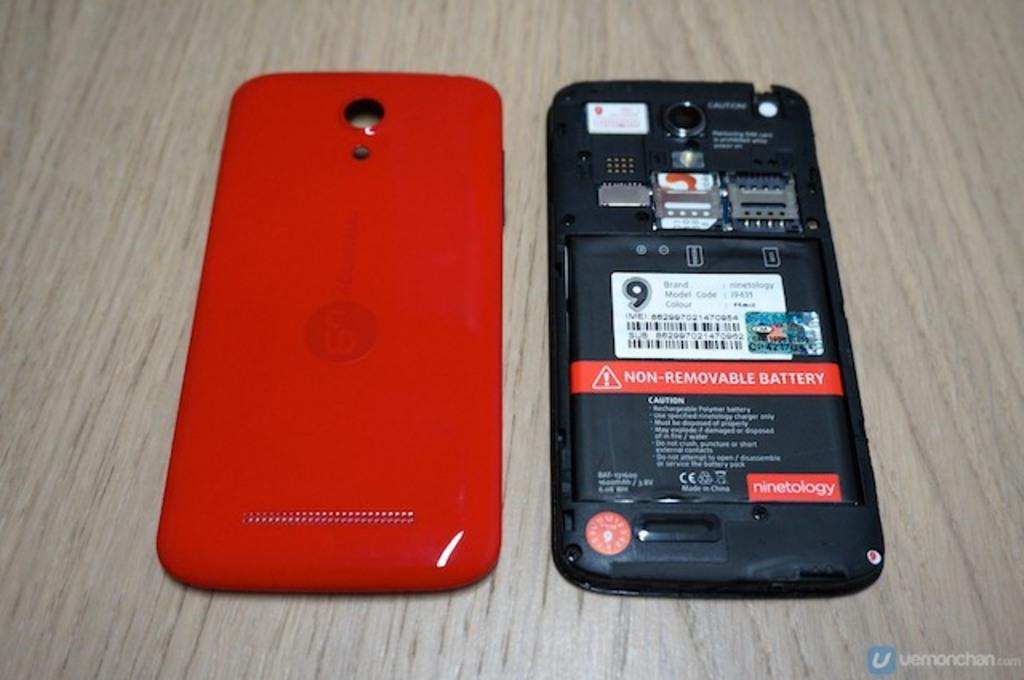<image>
Relay a brief, clear account of the picture shown. A phone with its red back removed and placed to the side now reveals its insides that say Non-Removable Battery. 